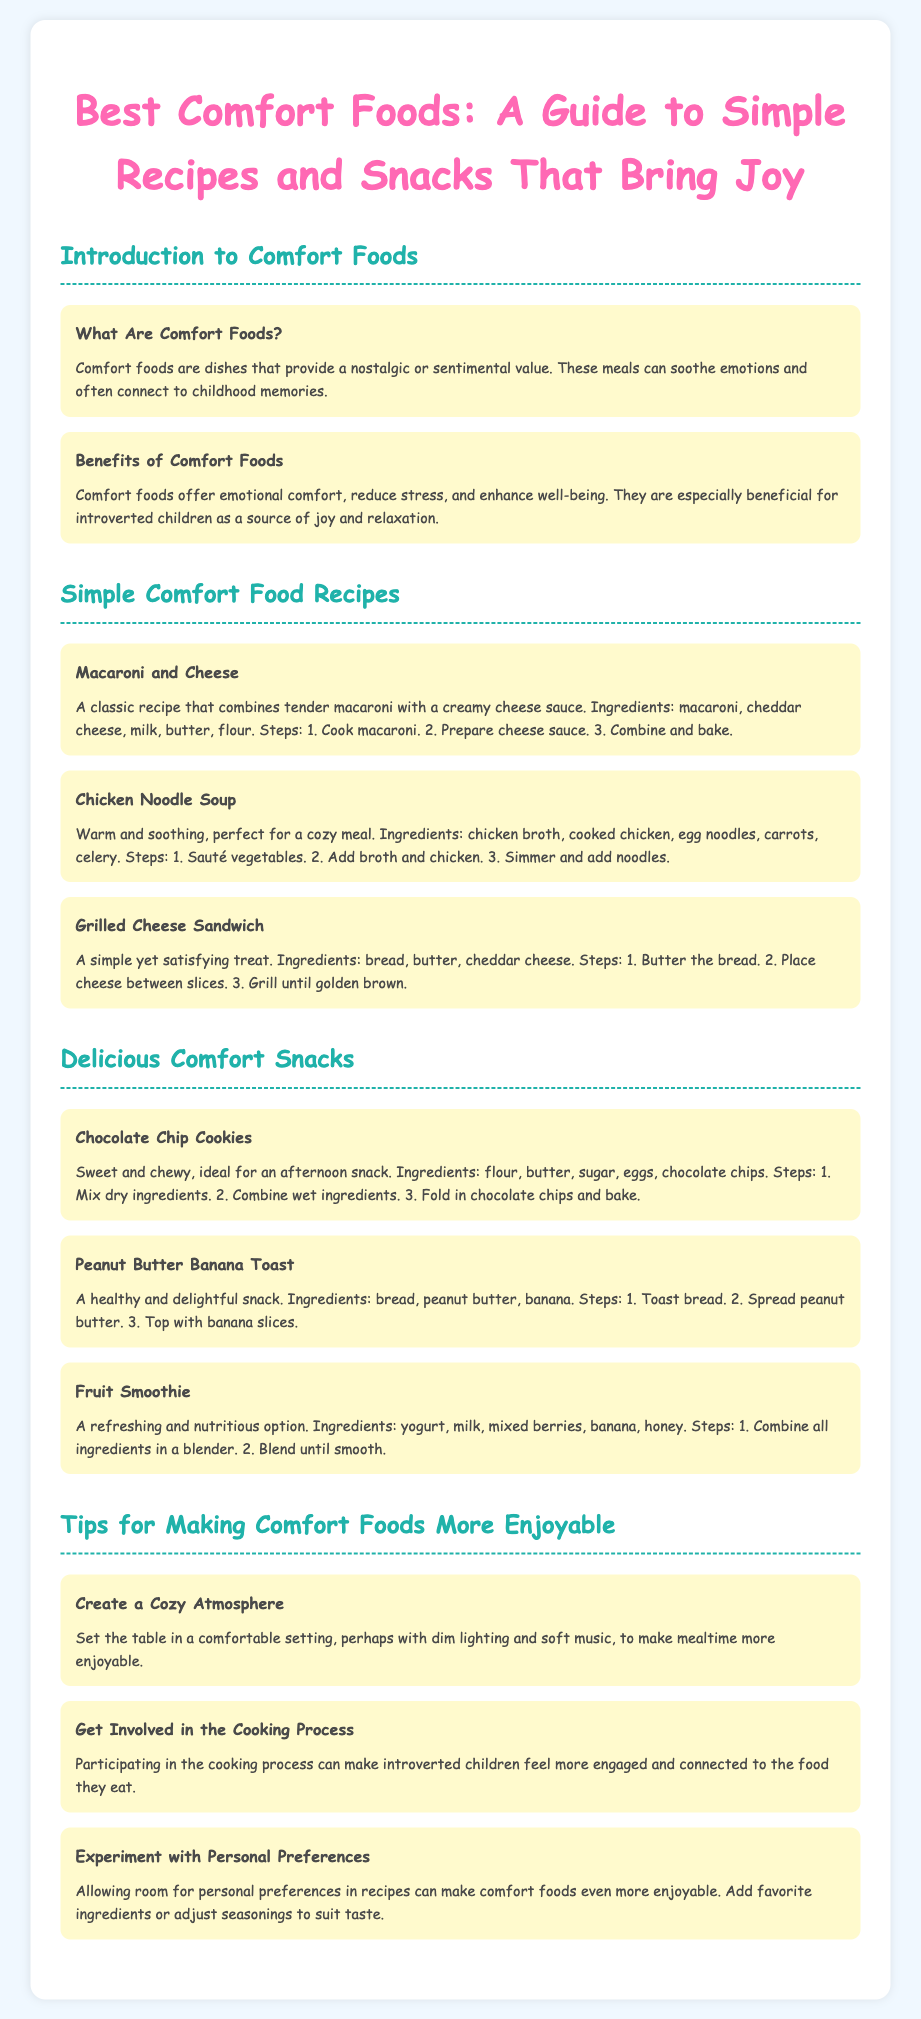What are comfort foods? Comfort foods are dishes that provide a nostalgic or sentimental value.
Answer: Dishes that provide nostalgia What is a key benefit of comfort foods? Comfort foods offer emotional comfort, reduce stress, and enhance well-being.
Answer: Emotional comfort How many simple comfort food recipes are listed? The document mentions three recipes under the Simple Comfort Food Recipes chapter.
Answer: Three What ingredients are needed for Chicken Noodle Soup? Ingredients listed include chicken broth, cooked chicken, egg noodles, carrots, celery.
Answer: Chicken broth, cooked chicken, egg noodles, carrots, celery What snack is described as healthy and delightful? The document mentions Peanut Butter Banana Toast as a healthy and delightful snack.
Answer: Peanut Butter Banana Toast What is one way to make comfort foods more enjoyable? One suggestion is to create a cozy atmosphere with dim lighting and soft music.
Answer: Create a cozy atmosphere Which recipe involves grilling? The Grilled Cheese Sandwich recipe involves grilling.
Answer: Grilled Cheese Sandwich How can introverted children feel more engaged during meals? Participating in the cooking process can help them feel more engaged.
Answer: Get involved in the cooking process 